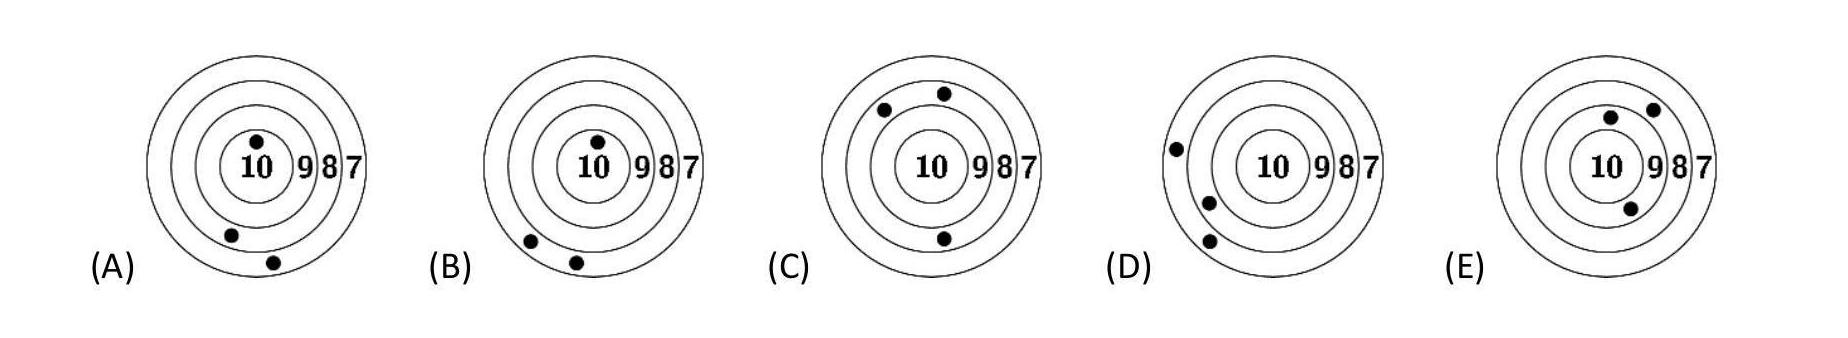Five boys competed in a shooting challenge. Ricky scored the most points. Which target was Ricky's?
Choices: ['A', 'B', 'C', 'D', 'E'] Answer is E. 